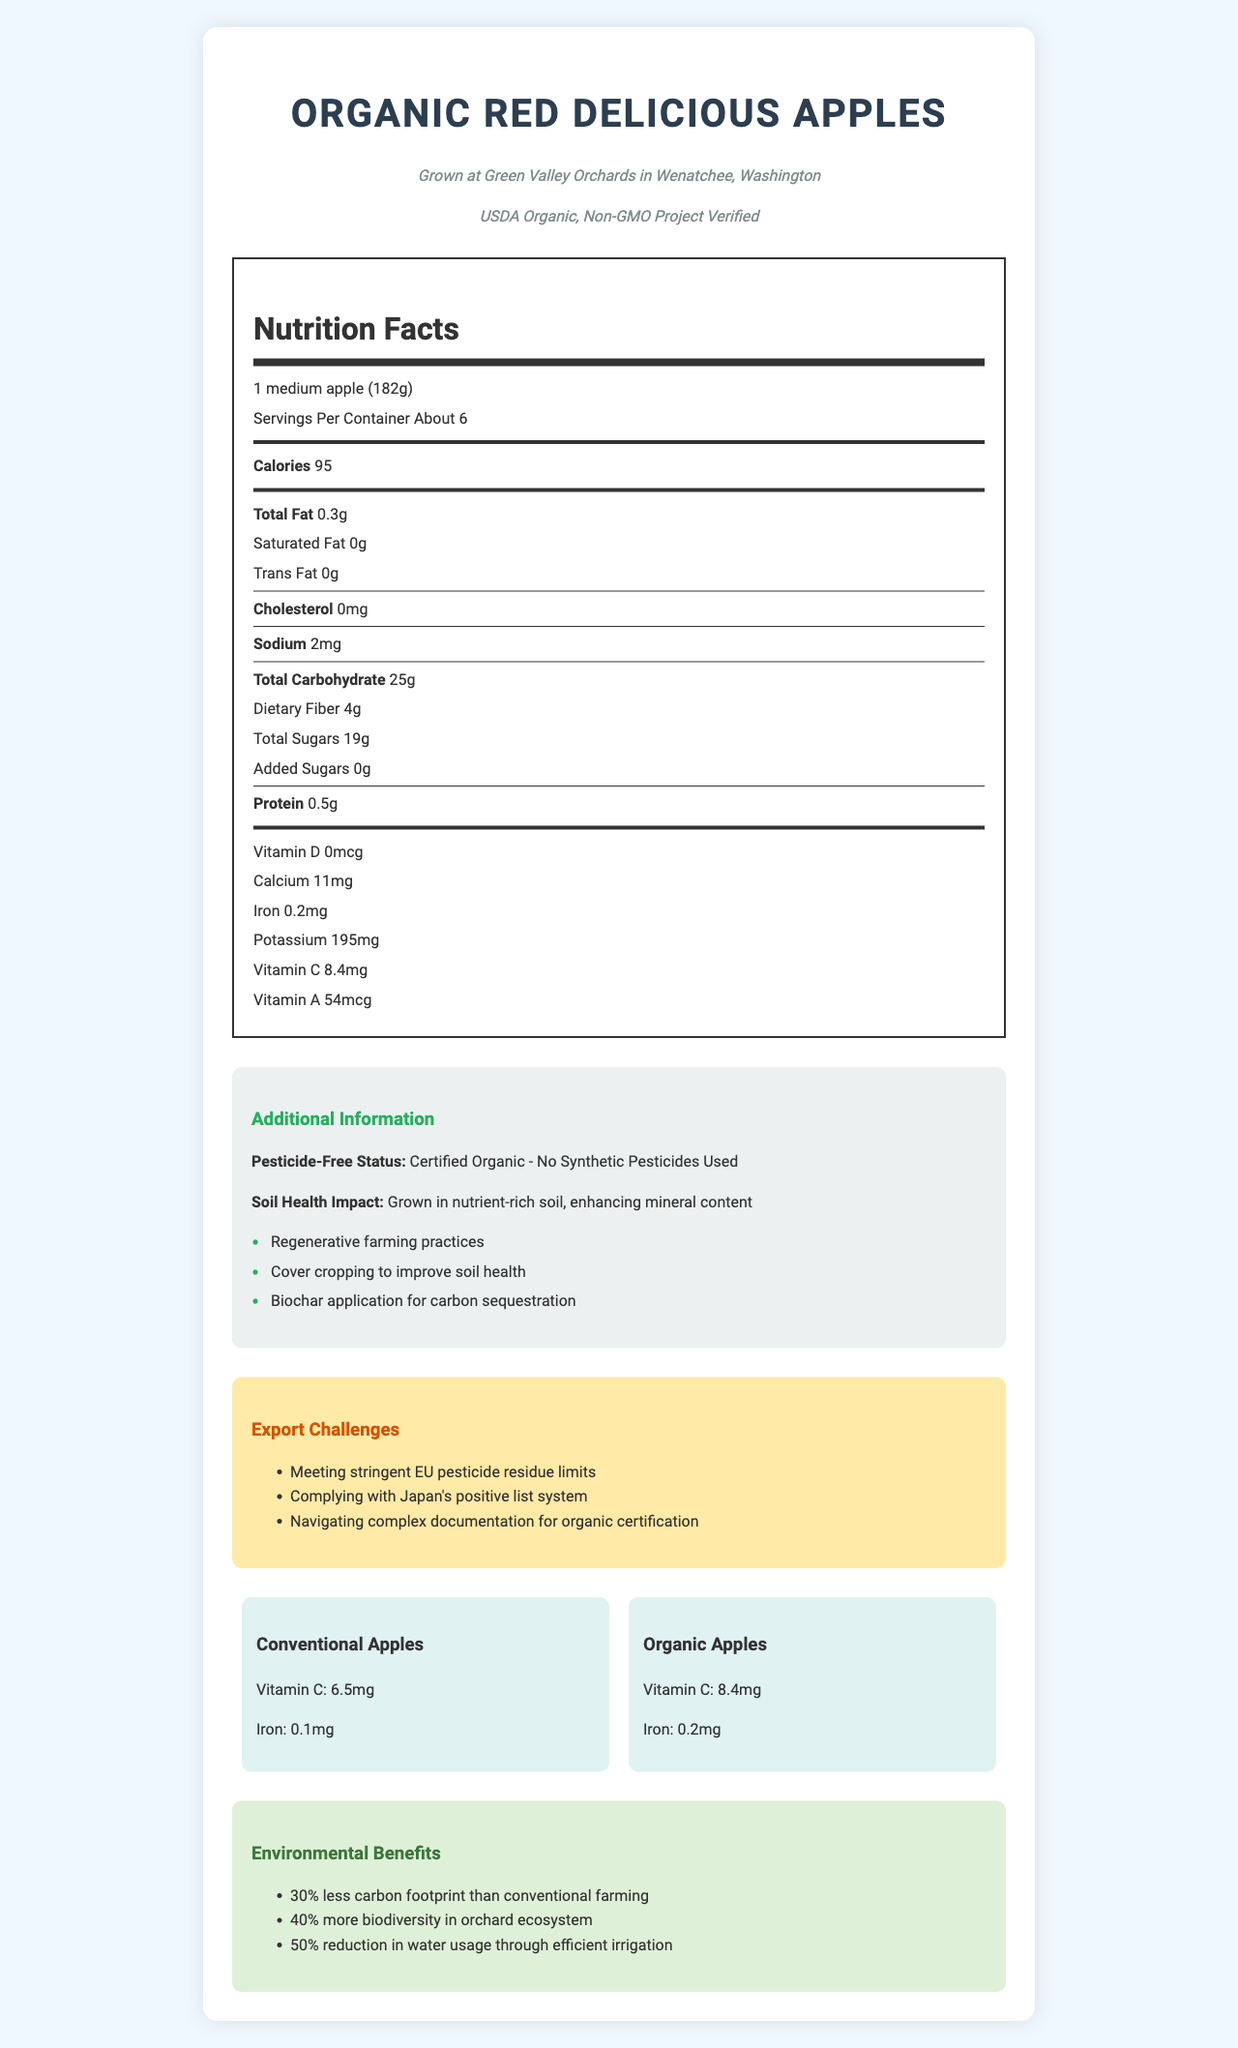What is the serving size for Organic Red Delicious Apples? The serving size is explicitly mentioned as "1 medium apple (182g)" in the Nutrition Facts section.
Answer: 1 medium apple (182g) How many calories are there per serving? The calories per serving are listed as 95 in the Nutrition Facts section.
Answer: 95 What is the total carbohydrate content in one serving? The total carbohydrate content per serving is indicated as 25g in the Nutrition Facts section.
Answer: 25g What is the certified pesticide-free status of these apples? The document states "Certified Organic - No Synthetic Pesticides Used" under the Additional Information section.
Answer: Certified Organic - No Synthetic Pesticides Used How much Vitamin C does one serving of these apples contain? The Vitamin C content per serving is specified as 8.4mg in the Nutrition Facts section.
Answer: 8.4mg What is the difference in Vitamin C content between organic and conventional apples? Organic apples contain 8.4mg of Vitamin C, while conventional apples contain 6.5mg. The difference is 1.9mg.
Answer: 1.9mg Which certification(s) do these apples have? A. USDA Organic B. Non-GMO Project Verified C. Fair Trade Certified D. Both A and B The certifications listed are USDA Organic and Non-GMO Project Verified.
Answer: D How does soil health impact the nutritional content of these apples? A. Increases pesticide residue B. Enhances mineral content C. Reduces water content D. Increases fat content The document states that nutrient-rich soil enhances mineral content.
Answer: B Are Organic Red Delicious Apples grown using synthetic pesticides? The document specifies that these apples are "Certified Organic - No Synthetic Pesticides Used".
Answer: No Summarize the entire document's main points. The detailed nutritional information highlights the benefits of these organic apples, including their certifications, farming practices, export challenges, and environmental impacts. The nutrient comparison shows higher Vitamin C and iron content in organic apples. The document also discusses various challenges faced in exporting these apples due to stringent regulations.
Answer: The document provides detailed nutritional facts for Organic Red Delicious Apples, emphasizing their certified organic status, free from synthetic pesticides, and grown in nutrient-rich soil. It compares the nutrient content to conventional apples, highlights additional farming practices for soil health, lists export challenges, and outlines environmental benefits. What farm grows these Organic Red Delicious Apples? The farm information section clearly states that these apples are grown at Green Valley Orchards.
Answer: Green Valley Orchards What challenges are mentioned for exporting these apples? The Export Challenges section lists these specific challenges.
Answer: Meeting stringent EU pesticide residue limits, Complying with Japan's positive list system, Navigating complex documentation for organic certification Can you determine the exact price of these apples from the document? The document does not provide any information regarding the price of the apples.
Answer: Cannot be determined What are the environmental benefits of these apples' farming practices mentioned in the document? The Environmental Benefits section details these specific benefits.
Answer: 30% less carbon footprint, 40% more biodiversity, 50% reduction in water usage Where are these apples grown? The farm information specifies that these apples are grown in Wenatchee, Washington.
Answer: Wenatchee, Washington 